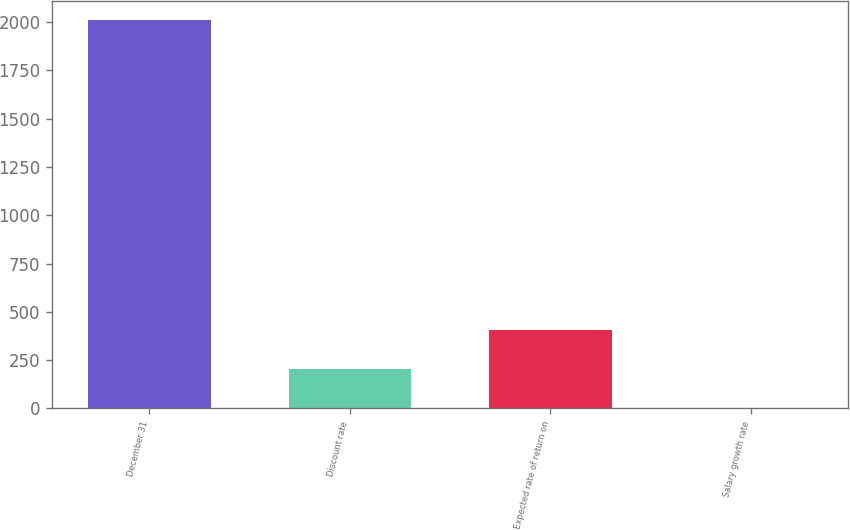Convert chart. <chart><loc_0><loc_0><loc_500><loc_500><bar_chart><fcel>December 31<fcel>Discount rate<fcel>Expected rate of return on<fcel>Salary growth rate<nl><fcel>2008<fcel>204.67<fcel>405.04<fcel>4.3<nl></chart> 